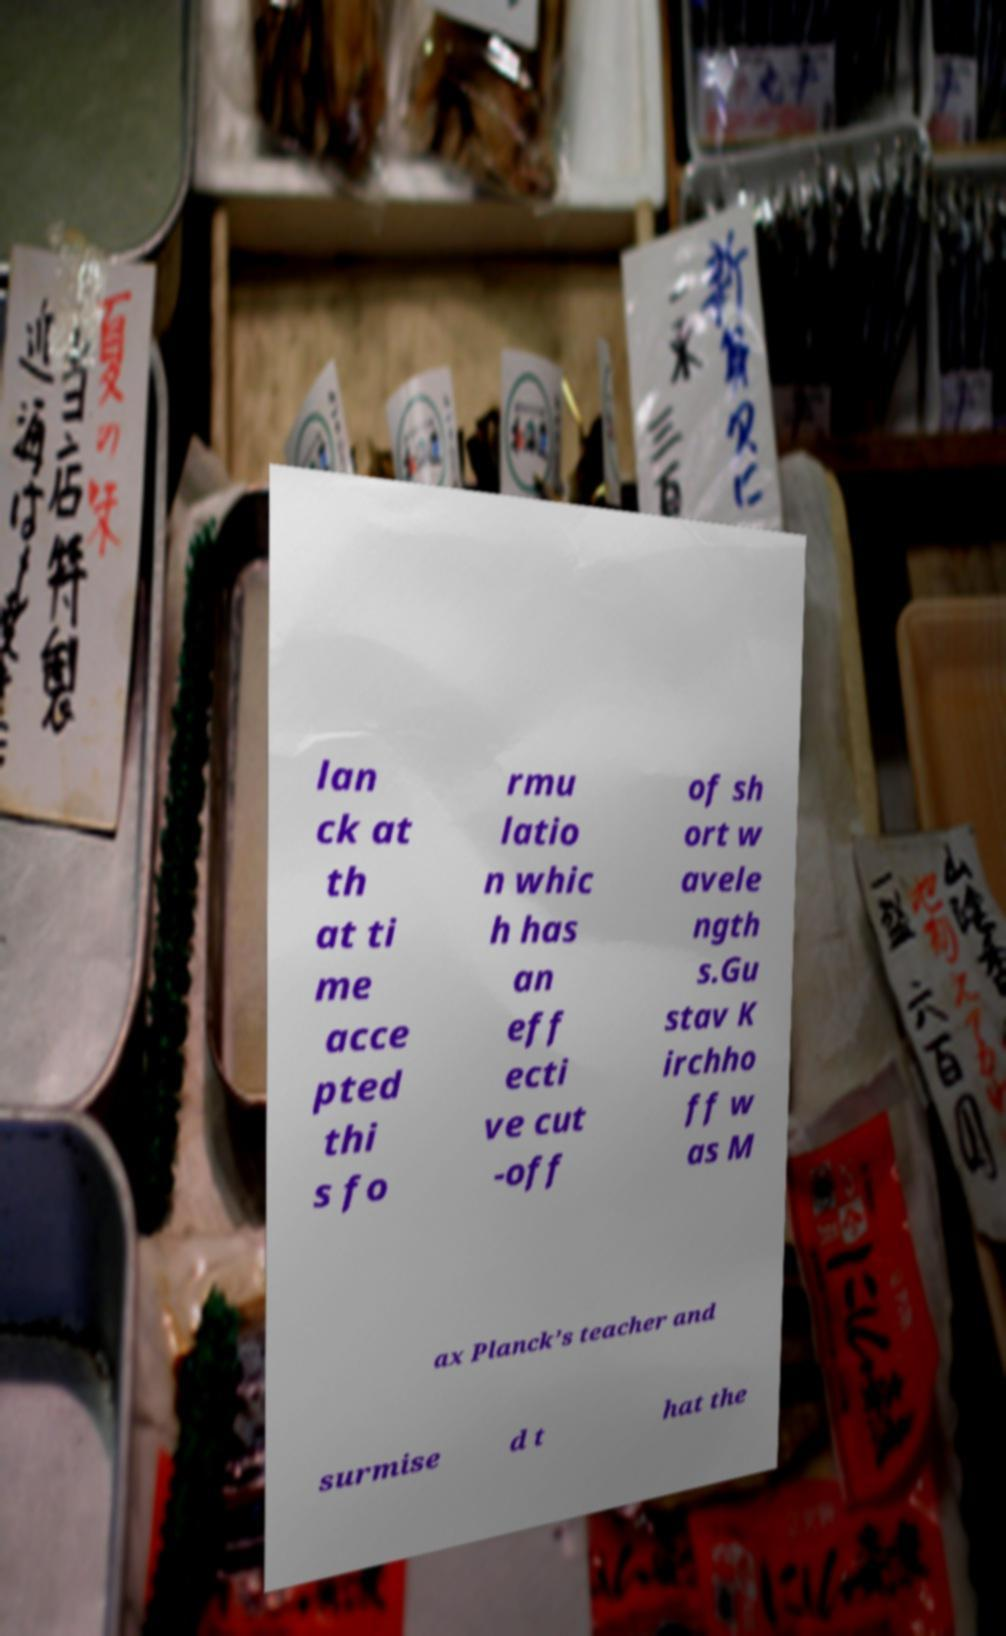I need the written content from this picture converted into text. Can you do that? lan ck at th at ti me acce pted thi s fo rmu latio n whic h has an eff ecti ve cut -off of sh ort w avele ngth s.Gu stav K irchho ff w as M ax Planck’s teacher and surmise d t hat the 